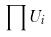<formula> <loc_0><loc_0><loc_500><loc_500>\prod U _ { i }</formula> 